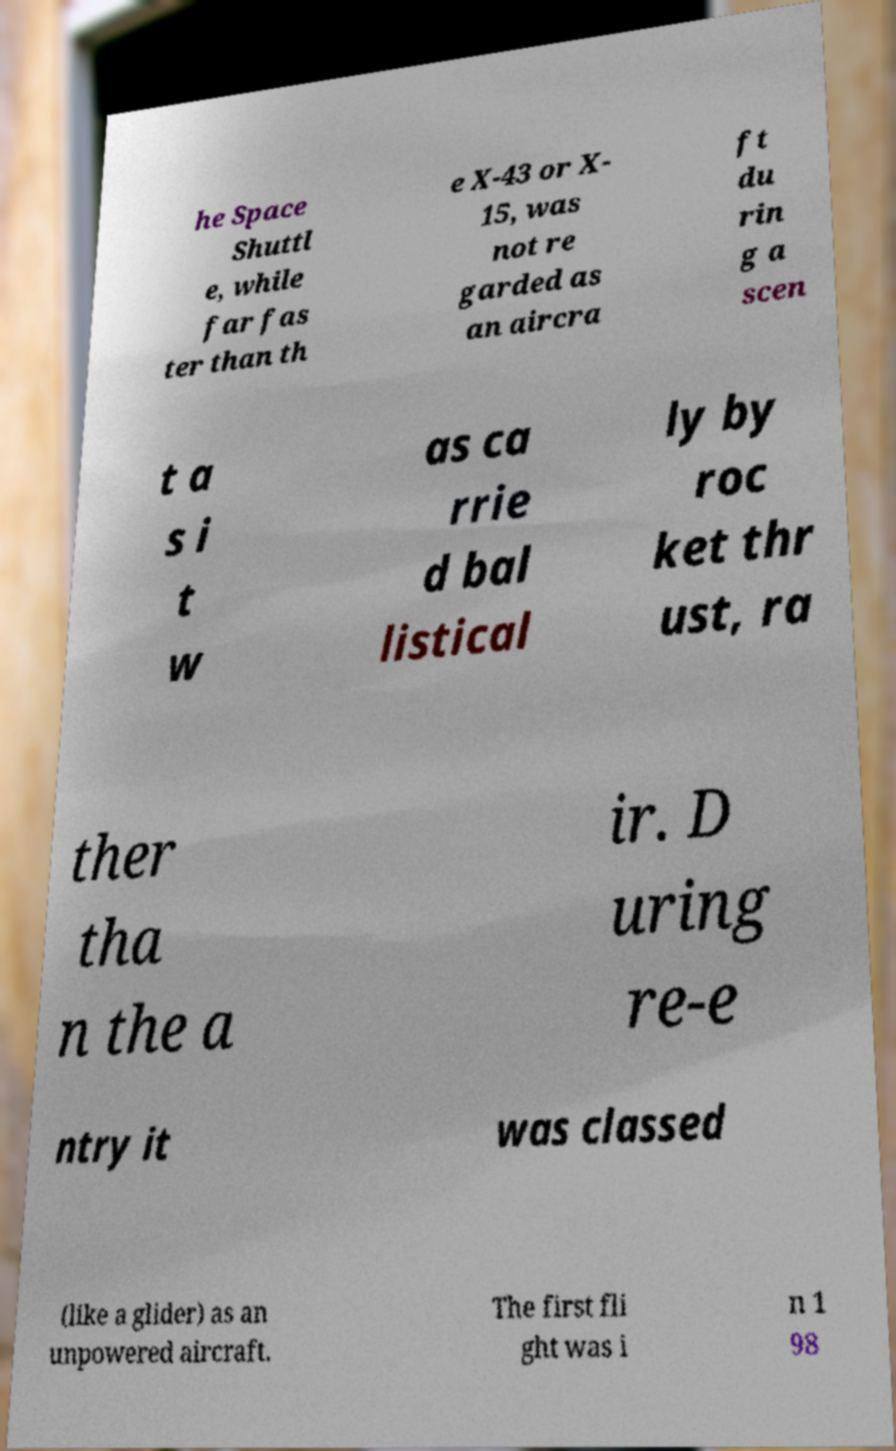Please identify and transcribe the text found in this image. he Space Shuttl e, while far fas ter than th e X-43 or X- 15, was not re garded as an aircra ft du rin g a scen t a s i t w as ca rrie d bal listical ly by roc ket thr ust, ra ther tha n the a ir. D uring re-e ntry it was classed (like a glider) as an unpowered aircraft. The first fli ght was i n 1 98 